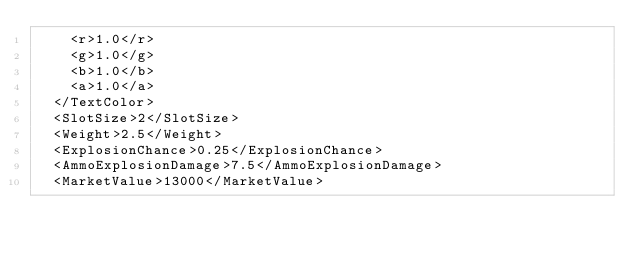Convert code to text. <code><loc_0><loc_0><loc_500><loc_500><_XML_>		<r>1.0</r>
		<g>1.0</g>
		<b>1.0</b>
		<a>1.0</a>
	</TextColor>
	<SlotSize>2</SlotSize>
	<Weight>2.5</Weight>
	<ExplosionChance>0.25</ExplosionChance>
	<AmmoExplosionDamage>7.5</AmmoExplosionDamage>
	<MarketValue>13000</MarketValue></code> 